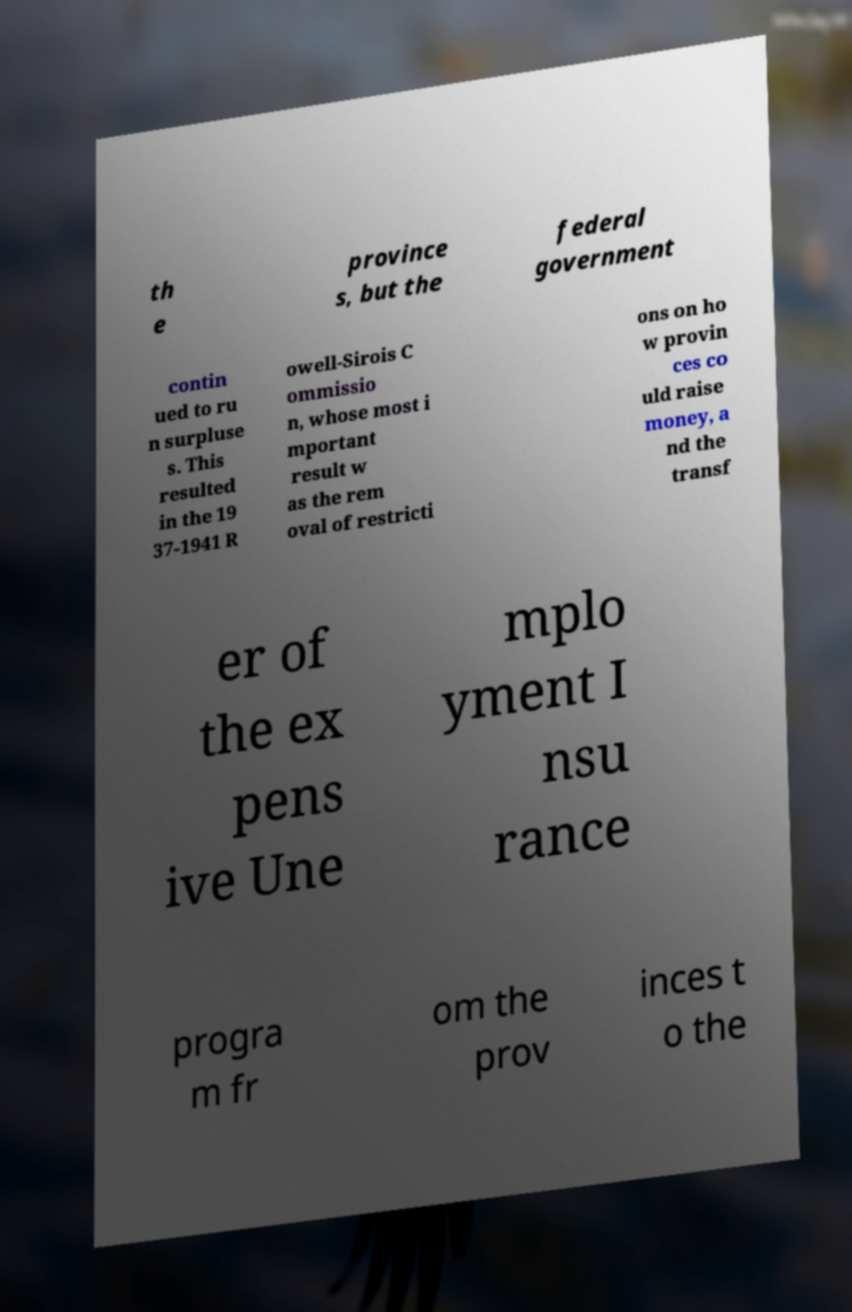I need the written content from this picture converted into text. Can you do that? th e province s, but the federal government contin ued to ru n surpluse s. This resulted in the 19 37-1941 R owell-Sirois C ommissio n, whose most i mportant result w as the rem oval of restricti ons on ho w provin ces co uld raise money, a nd the transf er of the ex pens ive Une mplo yment I nsu rance progra m fr om the prov inces t o the 